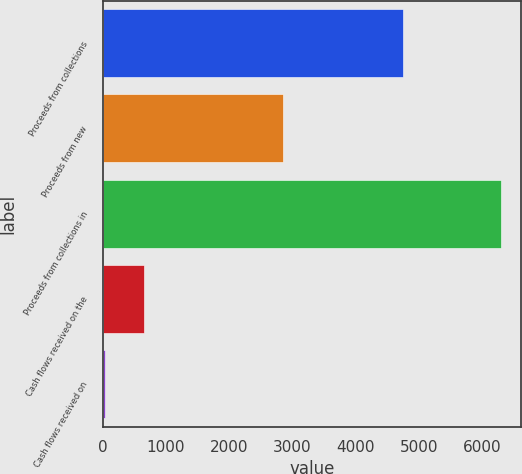<chart> <loc_0><loc_0><loc_500><loc_500><bar_chart><fcel>Proceeds from collections<fcel>Proceeds from new<fcel>Proceeds from collections in<fcel>Cash flows received on the<fcel>Cash flows received on<nl><fcel>4748.1<fcel>2844.4<fcel>6290.6<fcel>655.52<fcel>29.4<nl></chart> 